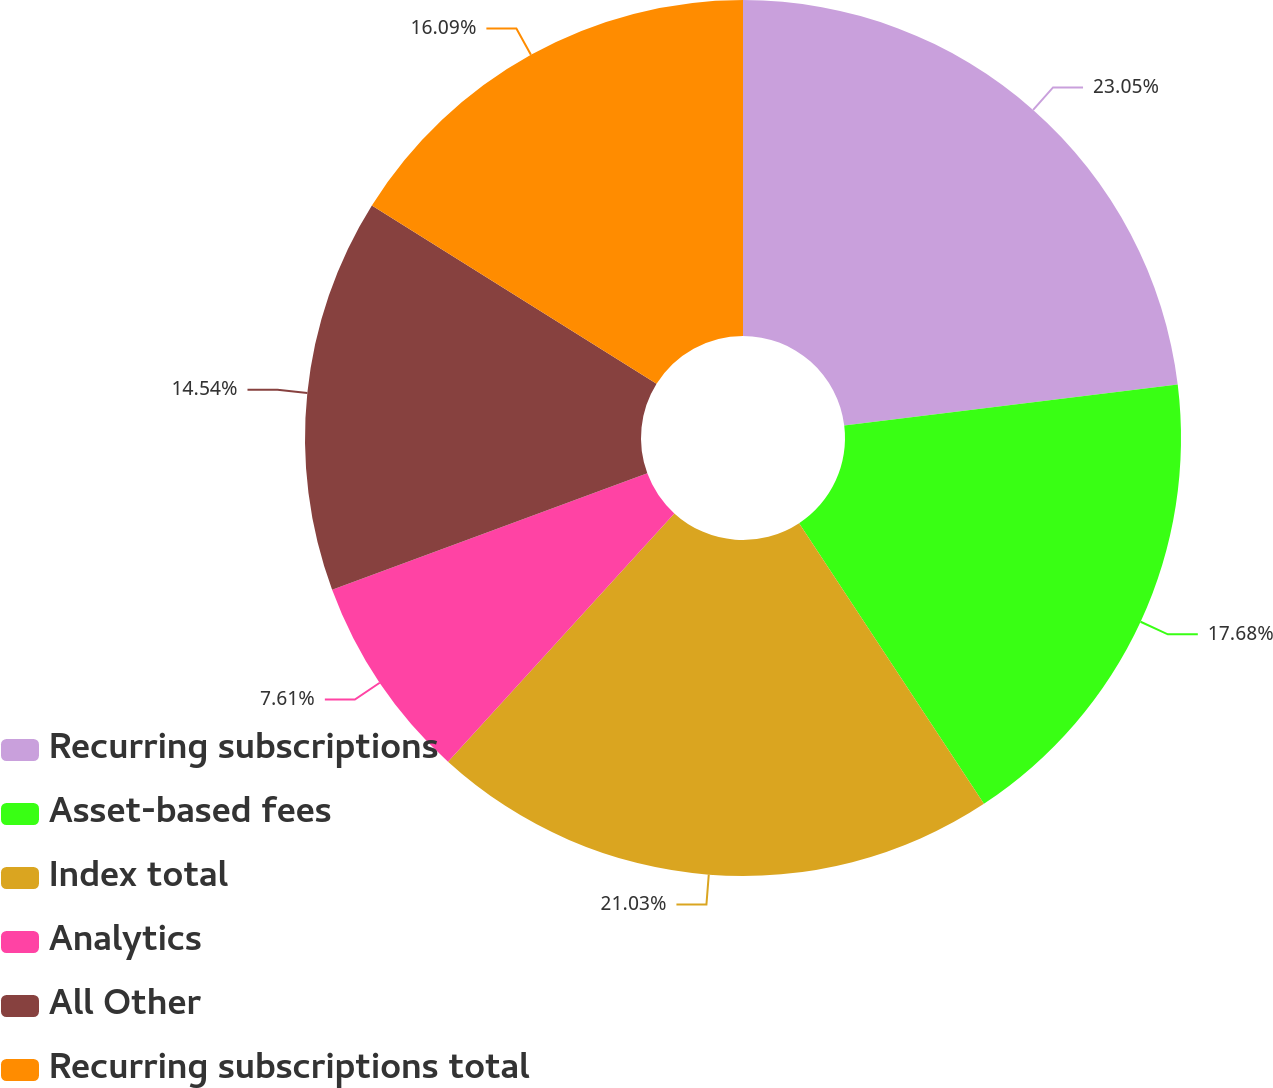Convert chart to OTSL. <chart><loc_0><loc_0><loc_500><loc_500><pie_chart><fcel>Recurring subscriptions<fcel>Asset-based fees<fcel>Index total<fcel>Analytics<fcel>All Other<fcel>Recurring subscriptions total<nl><fcel>23.05%<fcel>17.68%<fcel>21.03%<fcel>7.61%<fcel>14.54%<fcel>16.09%<nl></chart> 